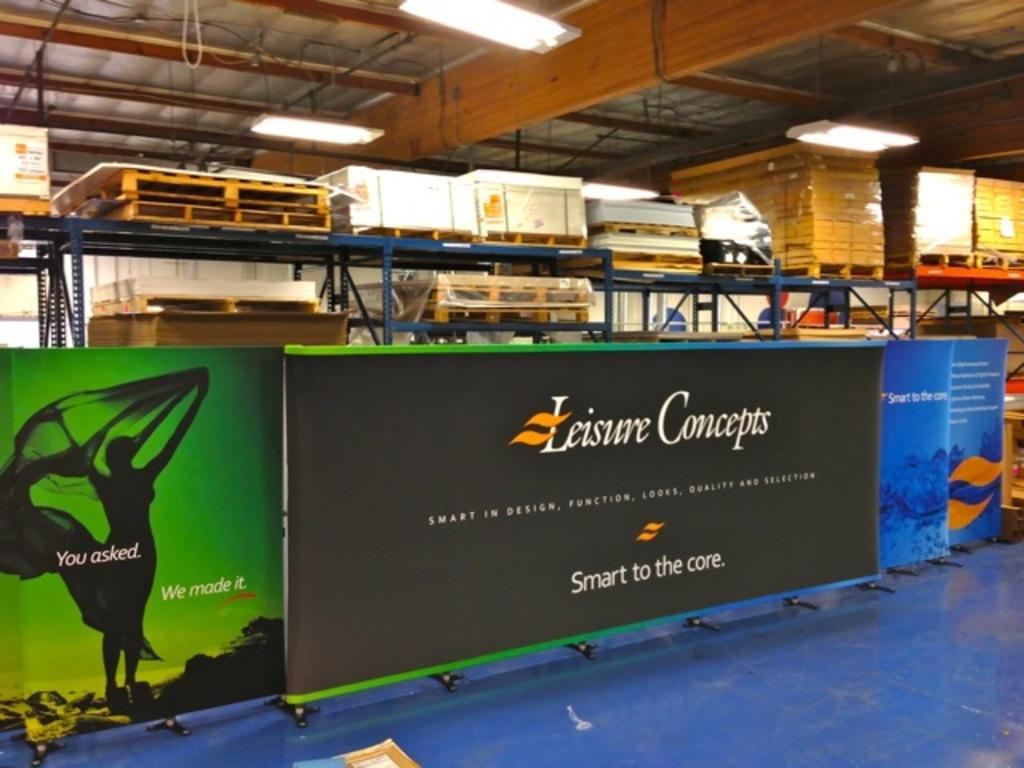<image>
Offer a succinct explanation of the picture presented. A billboard with Leisure concepts on top and smart to the core underneath. 